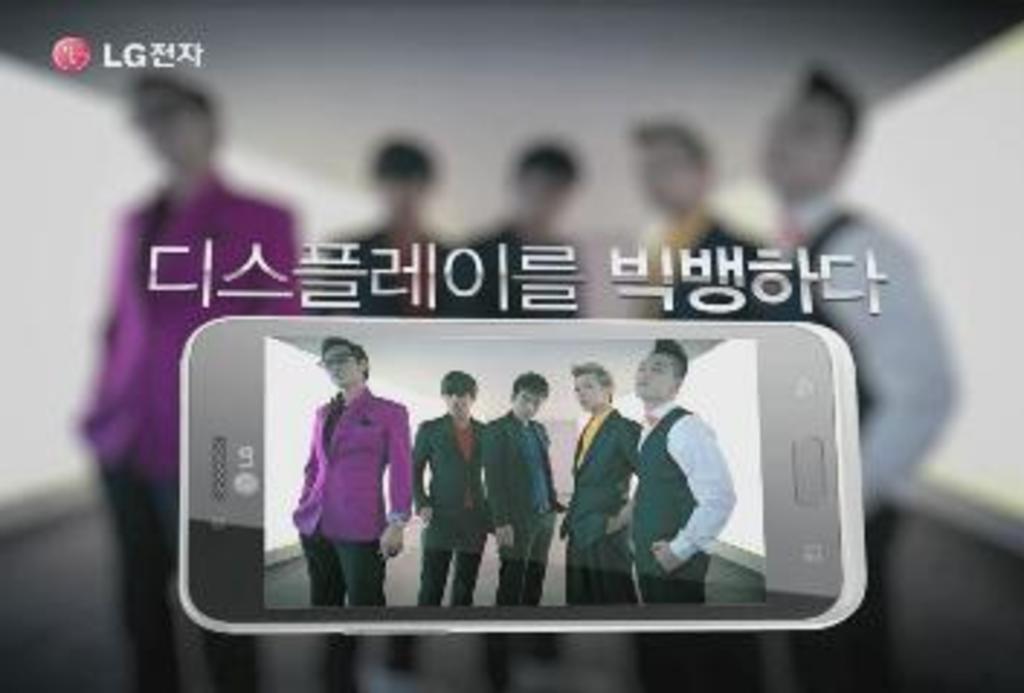How would you summarize this image in a sentence or two? In this picture I can observe four members in the mobile screen. All of them are wearing coats. There is some text in this picture. The background is blurred. 